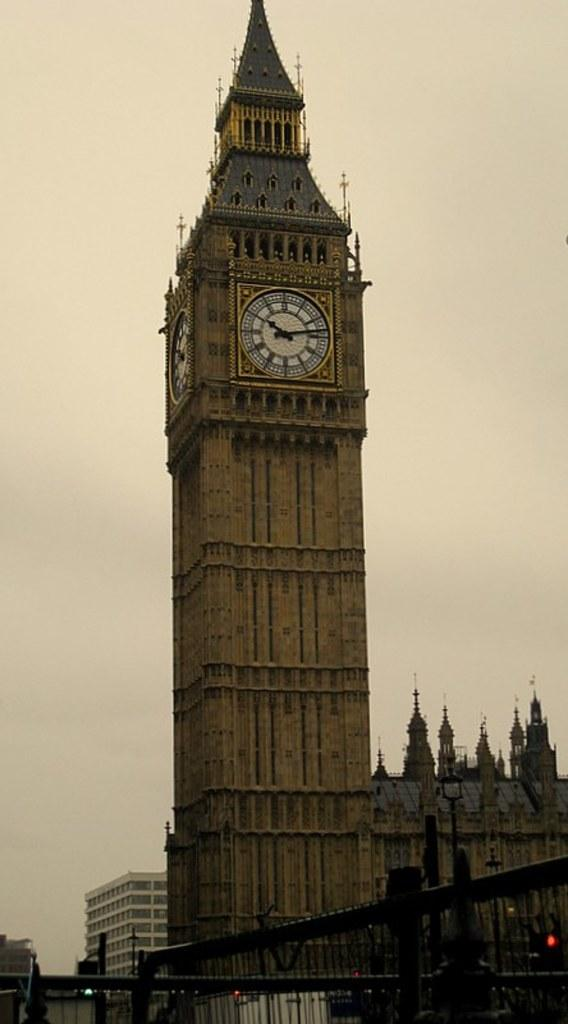What is the main structure in the image? There is a tower in the image. What feature is unique to the tower? The tower has 2 clocks. What other structures can be seen in the image? There are multiple buildings in the image. What type of barrier is present in the image? There is fencing visible in the image. What can be seen in the background of the image? The sky is visible in the background of the image. What type of whip is being played by the musician in the image? There is no musician or whip present in the image; it features a tower with 2 clocks and multiple buildings. How many dogs are visible in the image? There are no dogs present in the image. 